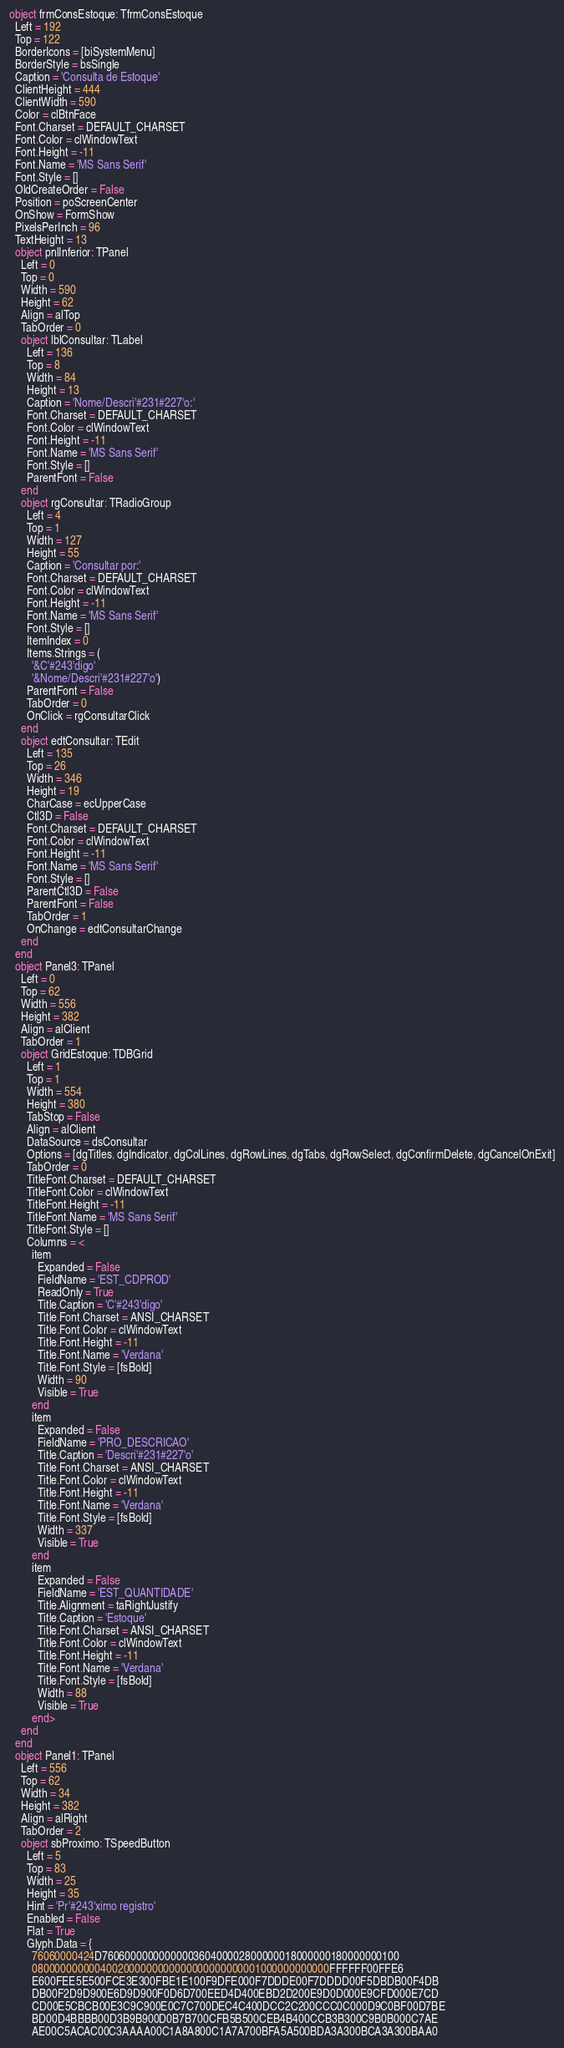<code> <loc_0><loc_0><loc_500><loc_500><_Pascal_>object frmConsEstoque: TfrmConsEstoque
  Left = 192
  Top = 122
  BorderIcons = [biSystemMenu]
  BorderStyle = bsSingle
  Caption = 'Consulta de Estoque'
  ClientHeight = 444
  ClientWidth = 590
  Color = clBtnFace
  Font.Charset = DEFAULT_CHARSET
  Font.Color = clWindowText
  Font.Height = -11
  Font.Name = 'MS Sans Serif'
  Font.Style = []
  OldCreateOrder = False
  Position = poScreenCenter
  OnShow = FormShow
  PixelsPerInch = 96
  TextHeight = 13
  object pnlInferior: TPanel
    Left = 0
    Top = 0
    Width = 590
    Height = 62
    Align = alTop
    TabOrder = 0
    object lblConsultar: TLabel
      Left = 136
      Top = 8
      Width = 84
      Height = 13
      Caption = 'Nome/Descri'#231#227'o:'
      Font.Charset = DEFAULT_CHARSET
      Font.Color = clWindowText
      Font.Height = -11
      Font.Name = 'MS Sans Serif'
      Font.Style = []
      ParentFont = False
    end
    object rgConsultar: TRadioGroup
      Left = 4
      Top = 1
      Width = 127
      Height = 55
      Caption = 'Consultar por:'
      Font.Charset = DEFAULT_CHARSET
      Font.Color = clWindowText
      Font.Height = -11
      Font.Name = 'MS Sans Serif'
      Font.Style = []
      ItemIndex = 0
      Items.Strings = (
        '&C'#243'digo'
        '&Nome/Descri'#231#227'o')
      ParentFont = False
      TabOrder = 0
      OnClick = rgConsultarClick
    end
    object edtConsultar: TEdit
      Left = 135
      Top = 26
      Width = 346
      Height = 19
      CharCase = ecUpperCase
      Ctl3D = False
      Font.Charset = DEFAULT_CHARSET
      Font.Color = clWindowText
      Font.Height = -11
      Font.Name = 'MS Sans Serif'
      Font.Style = []
      ParentCtl3D = False
      ParentFont = False
      TabOrder = 1
      OnChange = edtConsultarChange
    end
  end
  object Panel3: TPanel
    Left = 0
    Top = 62
    Width = 556
    Height = 382
    Align = alClient
    TabOrder = 1
    object GridEstoque: TDBGrid
      Left = 1
      Top = 1
      Width = 554
      Height = 380
      TabStop = False
      Align = alClient
      DataSource = dsConsultar
      Options = [dgTitles, dgIndicator, dgColLines, dgRowLines, dgTabs, dgRowSelect, dgConfirmDelete, dgCancelOnExit]
      TabOrder = 0
      TitleFont.Charset = DEFAULT_CHARSET
      TitleFont.Color = clWindowText
      TitleFont.Height = -11
      TitleFont.Name = 'MS Sans Serif'
      TitleFont.Style = []
      Columns = <
        item
          Expanded = False
          FieldName = 'EST_CDPROD'
          ReadOnly = True
          Title.Caption = 'C'#243'digo'
          Title.Font.Charset = ANSI_CHARSET
          Title.Font.Color = clWindowText
          Title.Font.Height = -11
          Title.Font.Name = 'Verdana'
          Title.Font.Style = [fsBold]
          Width = 90
          Visible = True
        end
        item
          Expanded = False
          FieldName = 'PRO_DESCRICAO'
          Title.Caption = 'Descri'#231#227'o'
          Title.Font.Charset = ANSI_CHARSET
          Title.Font.Color = clWindowText
          Title.Font.Height = -11
          Title.Font.Name = 'Verdana'
          Title.Font.Style = [fsBold]
          Width = 337
          Visible = True
        end
        item
          Expanded = False
          FieldName = 'EST_QUANTIDADE'
          Title.Alignment = taRightJustify
          Title.Caption = 'Estoque'
          Title.Font.Charset = ANSI_CHARSET
          Title.Font.Color = clWindowText
          Title.Font.Height = -11
          Title.Font.Name = 'Verdana'
          Title.Font.Style = [fsBold]
          Width = 88
          Visible = True
        end>
    end
  end
  object Panel1: TPanel
    Left = 556
    Top = 62
    Width = 34
    Height = 382
    Align = alRight
    TabOrder = 2
    object sbProximo: TSpeedButton
      Left = 5
      Top = 83
      Width = 25
      Height = 35
      Hint = 'Pr'#243'ximo registro'
      Enabled = False
      Flat = True
      Glyph.Data = {
        76060000424D7606000000000000360400002800000018000000180000000100
        0800000000004002000000000000000000000001000000000000FFFFFF00FFE6
        E600FEE5E500FCE3E300FBE1E100F9DFE000F7DDDE00F7DDDD00F5DBDB00F4DB
        DB00F2D9D900E6D9D900F0D6D700EED4D400EBD2D200E9D0D000E9CFD000E7CD
        CD00E5CBCB00E3C9C900E0C7C700DEC4C400DCC2C200CCC0C000D9C0BF00D7BE
        BD00D4BBBB00D3B9B900D0B7B700CFB5B500CEB4B400CCB3B300C9B0B000C7AE
        AE00C5ACAC00C3AAAA00C1A8A800C1A7A700BFA5A500BDA3A300BCA3A300BAA0</code> 